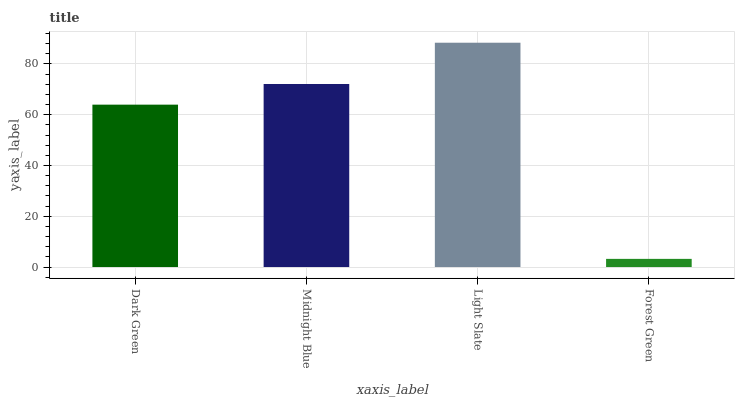Is Forest Green the minimum?
Answer yes or no. Yes. Is Light Slate the maximum?
Answer yes or no. Yes. Is Midnight Blue the minimum?
Answer yes or no. No. Is Midnight Blue the maximum?
Answer yes or no. No. Is Midnight Blue greater than Dark Green?
Answer yes or no. Yes. Is Dark Green less than Midnight Blue?
Answer yes or no. Yes. Is Dark Green greater than Midnight Blue?
Answer yes or no. No. Is Midnight Blue less than Dark Green?
Answer yes or no. No. Is Midnight Blue the high median?
Answer yes or no. Yes. Is Dark Green the low median?
Answer yes or no. Yes. Is Light Slate the high median?
Answer yes or no. No. Is Forest Green the low median?
Answer yes or no. No. 